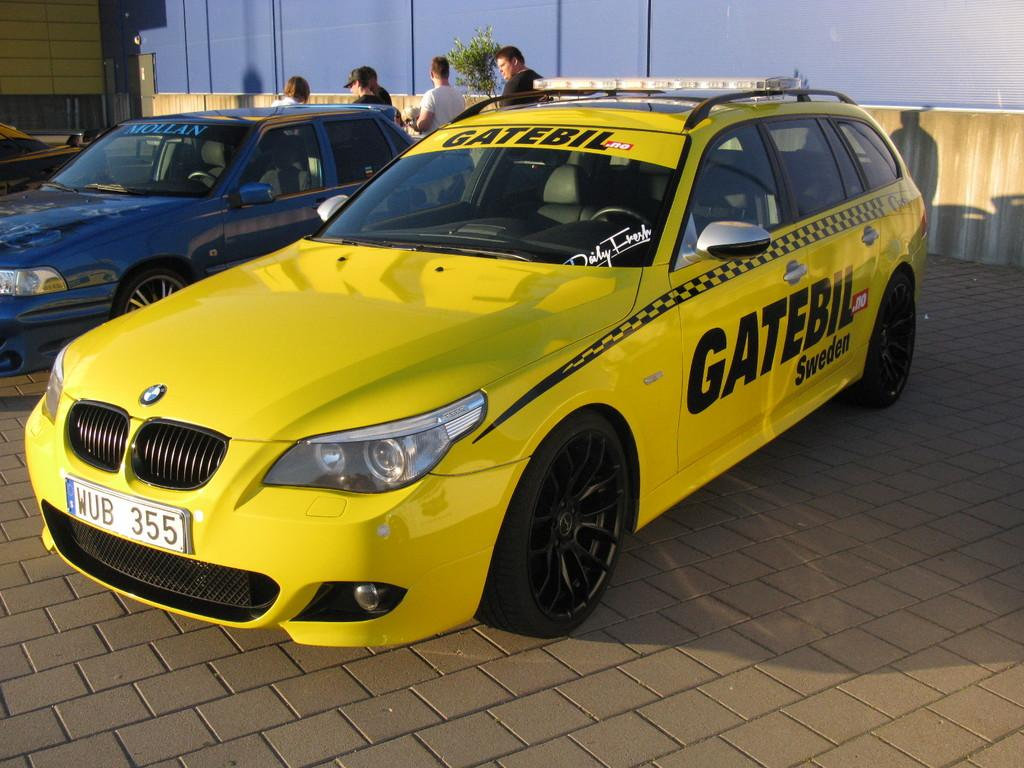<image>
Offer a succinct explanation of the picture presented. A yellow BMW with Gatebil written on the side. 